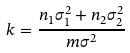<formula> <loc_0><loc_0><loc_500><loc_500>k = \frac { n _ { 1 } \sigma _ { 1 } ^ { 2 } + n _ { 2 } \sigma _ { 2 } ^ { 2 } } { m \sigma ^ { 2 } }</formula> 